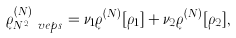<formula> <loc_0><loc_0><loc_500><loc_500>\varrho ^ { ( { N } ) } _ { N ^ { 2 } \ v e p s } = \nu _ { 1 } \varrho ^ { ( { N } ) } [ \rho _ { 1 } ] + \nu _ { 2 } \varrho ^ { ( { N } ) } [ \rho _ { 2 } ] ,</formula> 